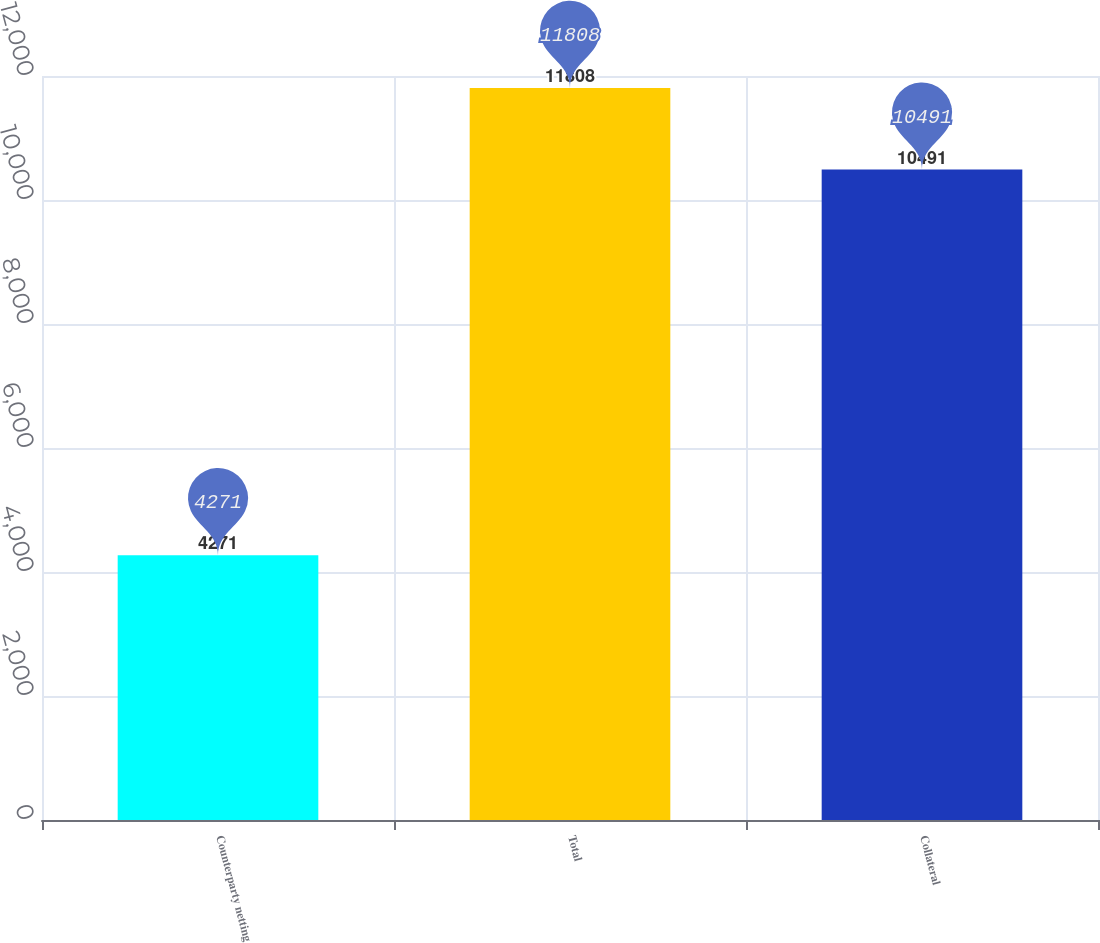Convert chart. <chart><loc_0><loc_0><loc_500><loc_500><bar_chart><fcel>Counterparty netting<fcel>Total<fcel>Collateral<nl><fcel>4271<fcel>11808<fcel>10491<nl></chart> 